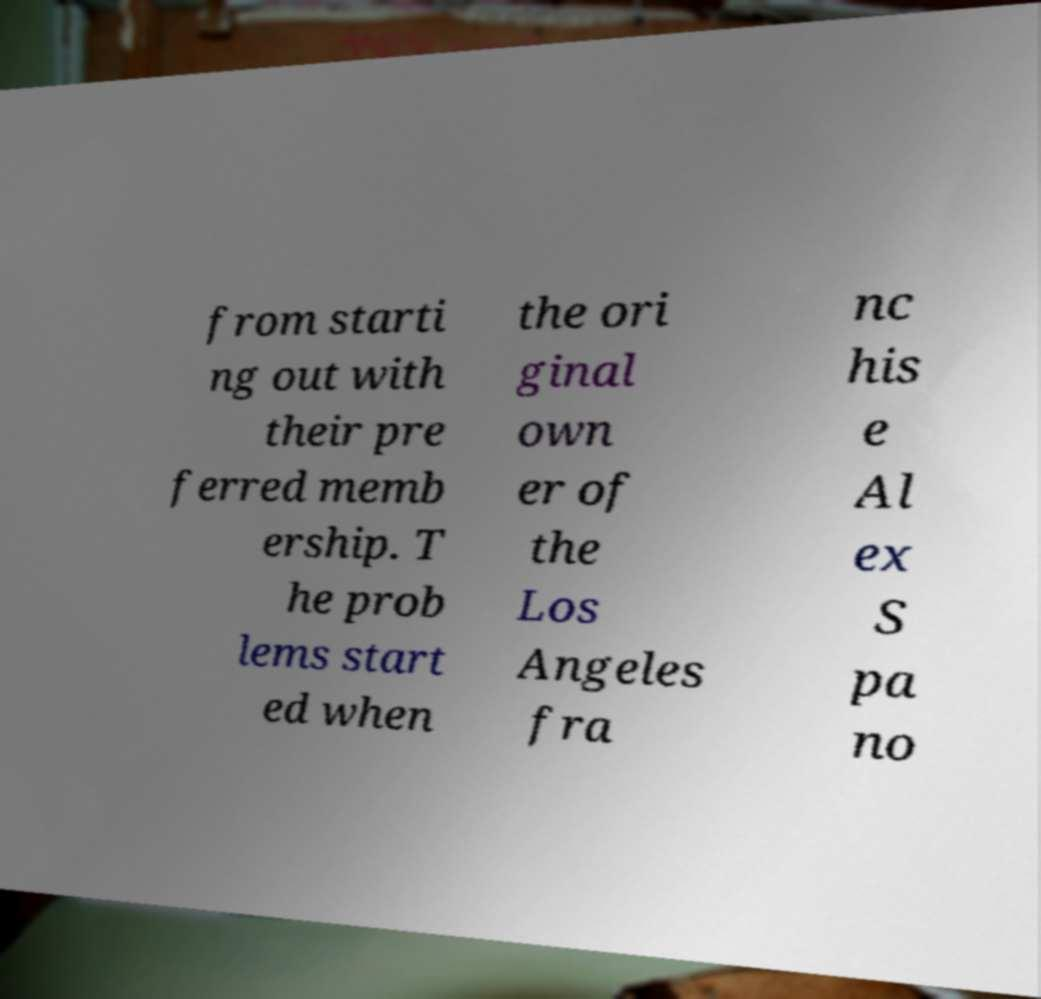What messages or text are displayed in this image? I need them in a readable, typed format. from starti ng out with their pre ferred memb ership. T he prob lems start ed when the ori ginal own er of the Los Angeles fra nc his e Al ex S pa no 